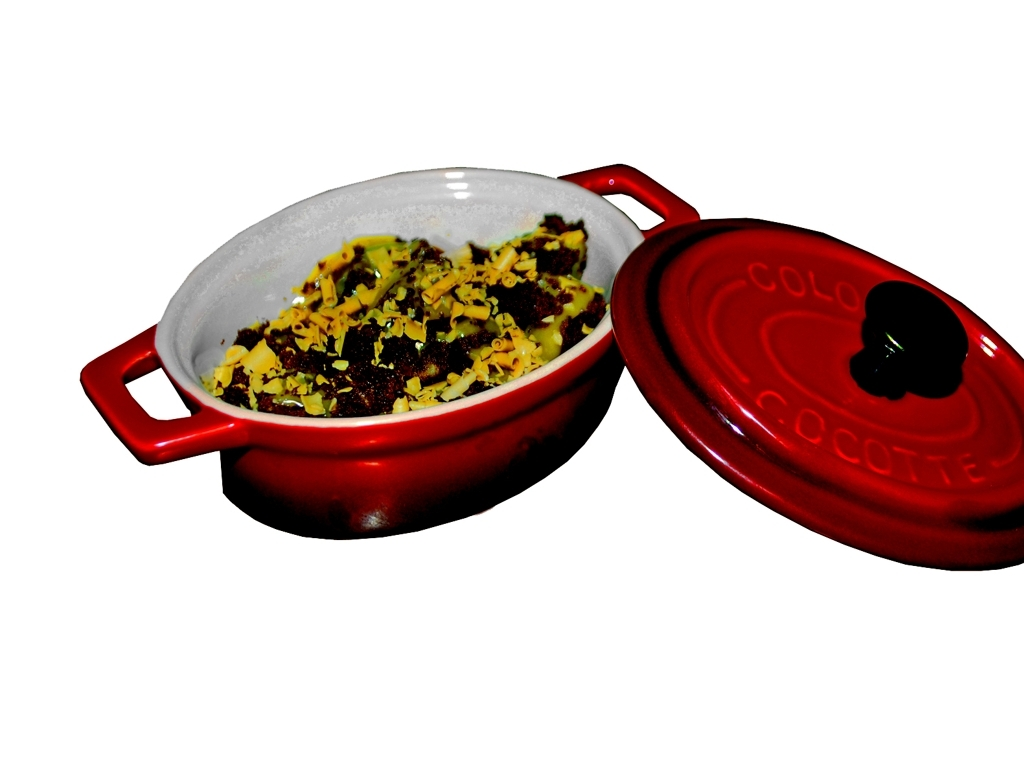How would you describe the background in this image? The background in this image is plain and nondescript, predominantly white, which accentuates the subject of the photograph—the colorful dish and its contents. This choice of background helps in focusing all the attention on the dish. 